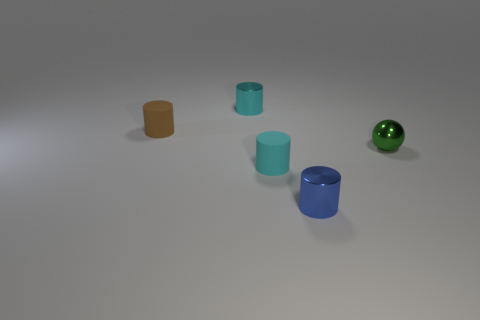There is a cyan cylinder that is made of the same material as the ball; what size is it? The cyan cylinder appears to be medium-sized relative to the other objects in the image, notably smaller than the green ball. 